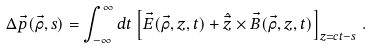<formula> <loc_0><loc_0><loc_500><loc_500>\Delta \vec { p } ( \vec { \rho } , s ) = \int _ { - \infty } ^ { \infty } d t \left [ \vec { E } ( \vec { \rho } , z , t ) + \hat { \vec { z } } \times \vec { B } ( \vec { \rho } , z , t ) \right ] _ { z = c t - s } \, .</formula> 